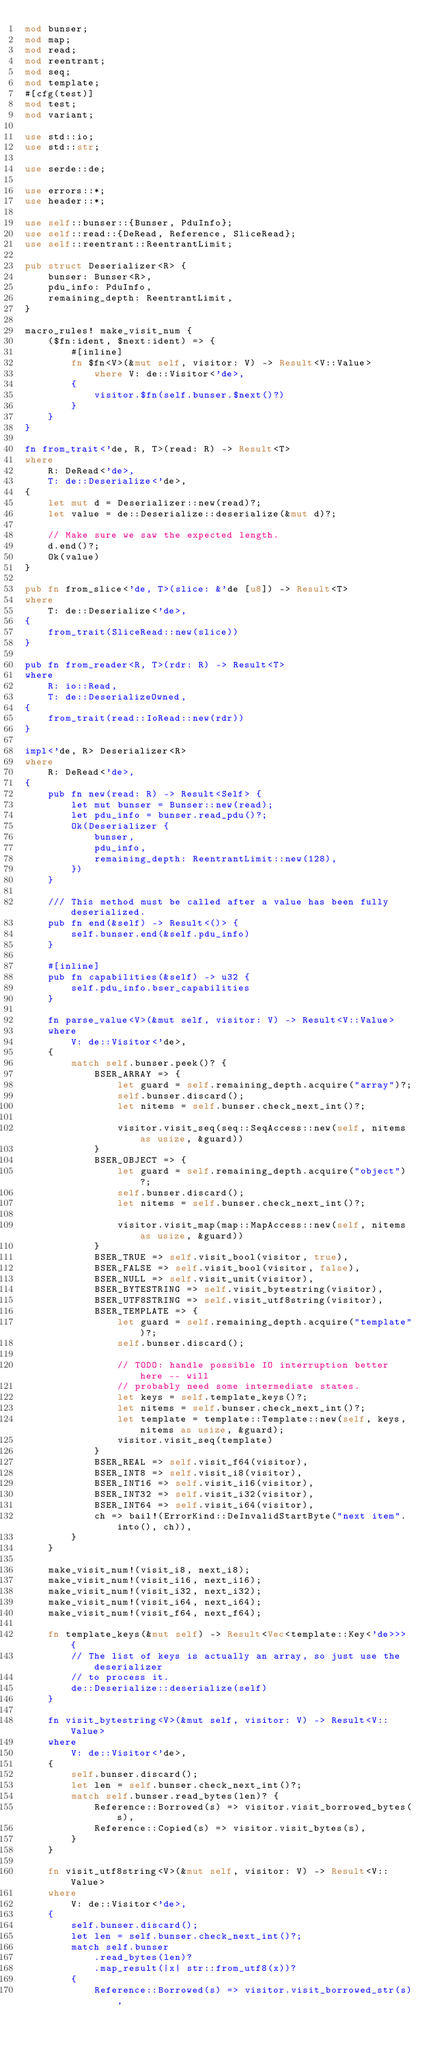<code> <loc_0><loc_0><loc_500><loc_500><_Rust_>mod bunser;
mod map;
mod read;
mod reentrant;
mod seq;
mod template;
#[cfg(test)]
mod test;
mod variant;

use std::io;
use std::str;

use serde::de;

use errors::*;
use header::*;

use self::bunser::{Bunser, PduInfo};
use self::read::{DeRead, Reference, SliceRead};
use self::reentrant::ReentrantLimit;

pub struct Deserializer<R> {
    bunser: Bunser<R>,
    pdu_info: PduInfo,
    remaining_depth: ReentrantLimit,
}

macro_rules! make_visit_num {
    ($fn:ident, $next:ident) => {
        #[inline]
        fn $fn<V>(&mut self, visitor: V) -> Result<V::Value>
            where V: de::Visitor<'de>,
        {
            visitor.$fn(self.bunser.$next()?)
        }
    }
}

fn from_trait<'de, R, T>(read: R) -> Result<T>
where
    R: DeRead<'de>,
    T: de::Deserialize<'de>,
{
    let mut d = Deserializer::new(read)?;
    let value = de::Deserialize::deserialize(&mut d)?;

    // Make sure we saw the expected length.
    d.end()?;
    Ok(value)
}

pub fn from_slice<'de, T>(slice: &'de [u8]) -> Result<T>
where
    T: de::Deserialize<'de>,
{
    from_trait(SliceRead::new(slice))
}

pub fn from_reader<R, T>(rdr: R) -> Result<T>
where
    R: io::Read,
    T: de::DeserializeOwned,
{
    from_trait(read::IoRead::new(rdr))
}

impl<'de, R> Deserializer<R>
where
    R: DeRead<'de>,
{
    pub fn new(read: R) -> Result<Self> {
        let mut bunser = Bunser::new(read);
        let pdu_info = bunser.read_pdu()?;
        Ok(Deserializer {
            bunser,
            pdu_info,
            remaining_depth: ReentrantLimit::new(128),
        })
    }

    /// This method must be called after a value has been fully deserialized.
    pub fn end(&self) -> Result<()> {
        self.bunser.end(&self.pdu_info)
    }

    #[inline]
    pub fn capabilities(&self) -> u32 {
        self.pdu_info.bser_capabilities
    }

    fn parse_value<V>(&mut self, visitor: V) -> Result<V::Value>
    where
        V: de::Visitor<'de>,
    {
        match self.bunser.peek()? {
            BSER_ARRAY => {
                let guard = self.remaining_depth.acquire("array")?;
                self.bunser.discard();
                let nitems = self.bunser.check_next_int()?;

                visitor.visit_seq(seq::SeqAccess::new(self, nitems as usize, &guard))
            }
            BSER_OBJECT => {
                let guard = self.remaining_depth.acquire("object")?;
                self.bunser.discard();
                let nitems = self.bunser.check_next_int()?;

                visitor.visit_map(map::MapAccess::new(self, nitems as usize, &guard))
            }
            BSER_TRUE => self.visit_bool(visitor, true),
            BSER_FALSE => self.visit_bool(visitor, false),
            BSER_NULL => self.visit_unit(visitor),
            BSER_BYTESTRING => self.visit_bytestring(visitor),
            BSER_UTF8STRING => self.visit_utf8string(visitor),
            BSER_TEMPLATE => {
                let guard = self.remaining_depth.acquire("template")?;
                self.bunser.discard();

                // TODO: handle possible IO interruption better here -- will
                // probably need some intermediate states.
                let keys = self.template_keys()?;
                let nitems = self.bunser.check_next_int()?;
                let template = template::Template::new(self, keys, nitems as usize, &guard);
                visitor.visit_seq(template)
            }
            BSER_REAL => self.visit_f64(visitor),
            BSER_INT8 => self.visit_i8(visitor),
            BSER_INT16 => self.visit_i16(visitor),
            BSER_INT32 => self.visit_i32(visitor),
            BSER_INT64 => self.visit_i64(visitor),
            ch => bail!(ErrorKind::DeInvalidStartByte("next item".into(), ch)),
        }
    }

    make_visit_num!(visit_i8, next_i8);
    make_visit_num!(visit_i16, next_i16);
    make_visit_num!(visit_i32, next_i32);
    make_visit_num!(visit_i64, next_i64);
    make_visit_num!(visit_f64, next_f64);

    fn template_keys(&mut self) -> Result<Vec<template::Key<'de>>> {
        // The list of keys is actually an array, so just use the deserializer
        // to process it.
        de::Deserialize::deserialize(self)
    }

    fn visit_bytestring<V>(&mut self, visitor: V) -> Result<V::Value>
    where
        V: de::Visitor<'de>,
    {
        self.bunser.discard();
        let len = self.bunser.check_next_int()?;
        match self.bunser.read_bytes(len)? {
            Reference::Borrowed(s) => visitor.visit_borrowed_bytes(s),
            Reference::Copied(s) => visitor.visit_bytes(s),
        }
    }

    fn visit_utf8string<V>(&mut self, visitor: V) -> Result<V::Value>
    where
        V: de::Visitor<'de>,
    {
        self.bunser.discard();
        let len = self.bunser.check_next_int()?;
        match self.bunser
            .read_bytes(len)?
            .map_result(|x| str::from_utf8(x))?
        {
            Reference::Borrowed(s) => visitor.visit_borrowed_str(s),</code> 